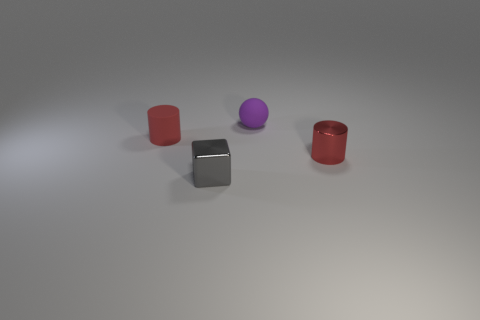Subtract all red cylinders. How many were subtracted if there are1red cylinders left? 1 Subtract all gray cylinders. Subtract all green blocks. How many cylinders are left? 2 Add 4 red things. How many objects exist? 8 Subtract all blocks. How many objects are left? 3 Subtract all blue things. Subtract all gray metallic objects. How many objects are left? 3 Add 3 purple balls. How many purple balls are left? 4 Add 2 purple matte balls. How many purple matte balls exist? 3 Subtract 0 gray cylinders. How many objects are left? 4 